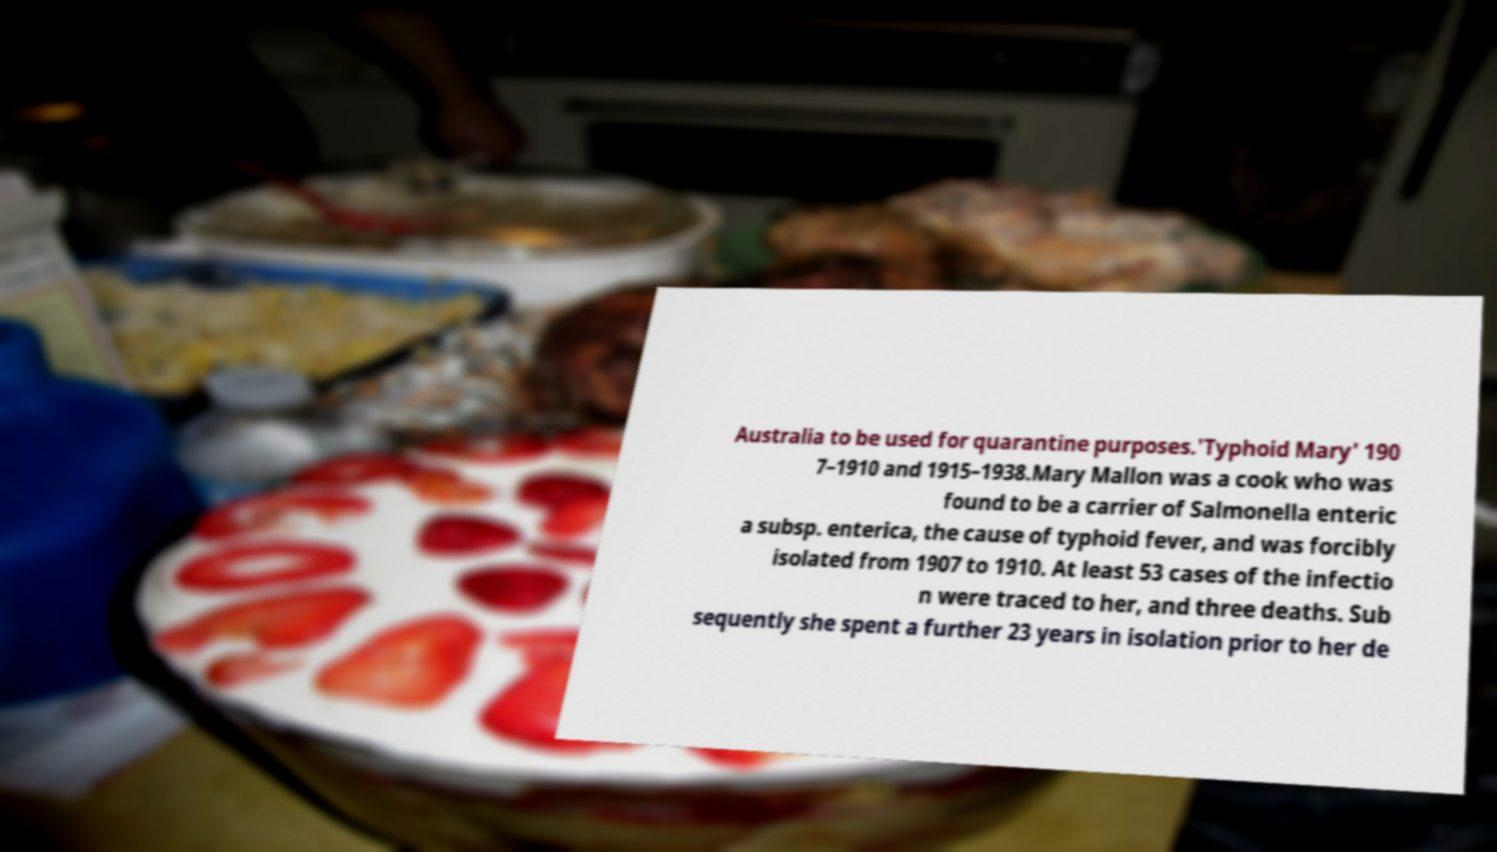For documentation purposes, I need the text within this image transcribed. Could you provide that? Australia to be used for quarantine purposes.'Typhoid Mary' 190 7–1910 and 1915–1938.Mary Mallon was a cook who was found to be a carrier of Salmonella enteric a subsp. enterica, the cause of typhoid fever, and was forcibly isolated from 1907 to 1910. At least 53 cases of the infectio n were traced to her, and three deaths. Sub sequently she spent a further 23 years in isolation prior to her de 